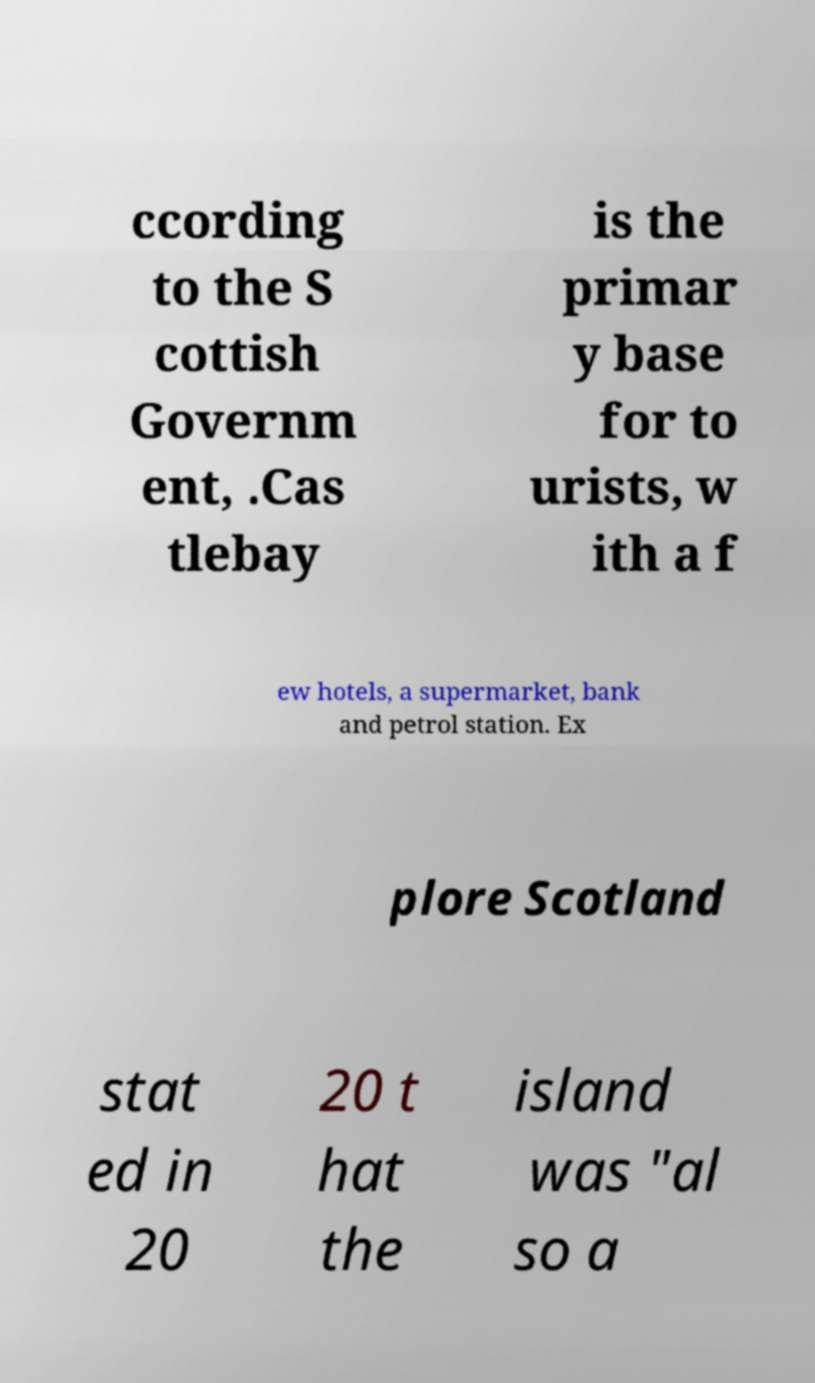What messages or text are displayed in this image? I need them in a readable, typed format. ccording to the S cottish Governm ent, .Cas tlebay is the primar y base for to urists, w ith a f ew hotels, a supermarket, bank and petrol station. Ex plore Scotland stat ed in 20 20 t hat the island was "al so a 